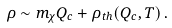<formula> <loc_0><loc_0><loc_500><loc_500>\rho \sim m _ { \chi } Q _ { c } + \rho _ { t h } ( Q _ { c } , T ) \, .</formula> 